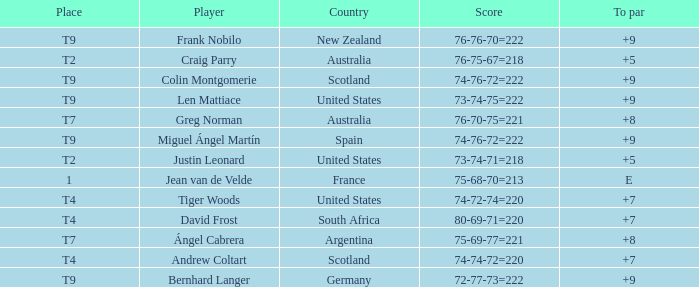What is the place number for the player with a To Par score of 'E'? 1.0. 